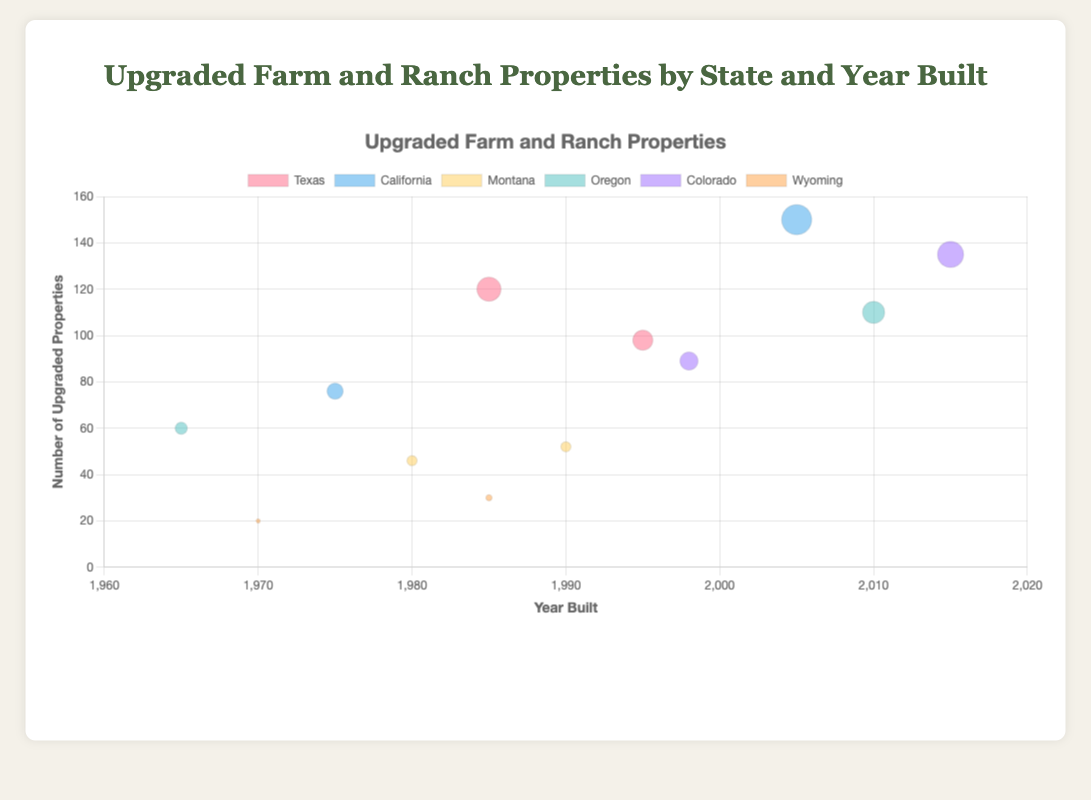what is the title of the figure? The title of the figure can be found at the top of the chart. It indicates the overall topic of the chart.
Answer: Upgraded Farm and Ranch Properties by State and Year Built How many upgraded properties were built in California in 2005? Look for the bubble corresponding to California near the 2005 mark on the x-axis. The y-axis value shows the number of upgraded properties.
Answer: 150 Which state has the bubble with the largest radius? The bubble with the largest radius represents the highest number of upgraded properties. Checking all bubbles, the one in California for the year 2005 appears to have the largest radius.
Answer: California What is the exact number of upgraded properties for the state with the largest radius bubble? Refer back to the specific bubble identified previously for California in 2005. The y-axis value for this bubble indicates the number of upgraded properties.
Answer: 150 Which states have data points for properties upgraded in the 1980s? Look along the x-axis between 1980 and 1989 and identify the states associated with the bubbles within this decade. The states are Texas, Montana, and Wyoming.
Answer: Texas, Montana, Wyoming What is the average number of upgraded properties for the Oregon state? Identify the bubbles for Oregon, read off the y-axis values, and calculate the average. Oregon has bubbles at 1965 with 60 properties and at 2010 with 110 properties. Average = (60 + 110) / 2.
Answer: 85 Compare the number of upgraded properties between Texas in 1985 and 1995. Which year had more properties upgraded? Locate Texas bubbles for years 1985 and 1995 on the x-axis, compare their y-axis values. Texas in 1985 had 120 properties while in 1995 had 98 properties.
Answer: 1985 Which state has consistently lower numbers of upgraded properties relative to others? Observe the bubbles with lower y-axis values and check which state labels they have. Wyoming has consistently lower values compared to other states, with 20 in 1970 and 30 in 1985.
Answer: Wyoming How many upgraded properties were there in Montana in 1990? Find the Montana bubble on the x-axis for the year 1990 and read its value off the y-axis.
Answer: 52 